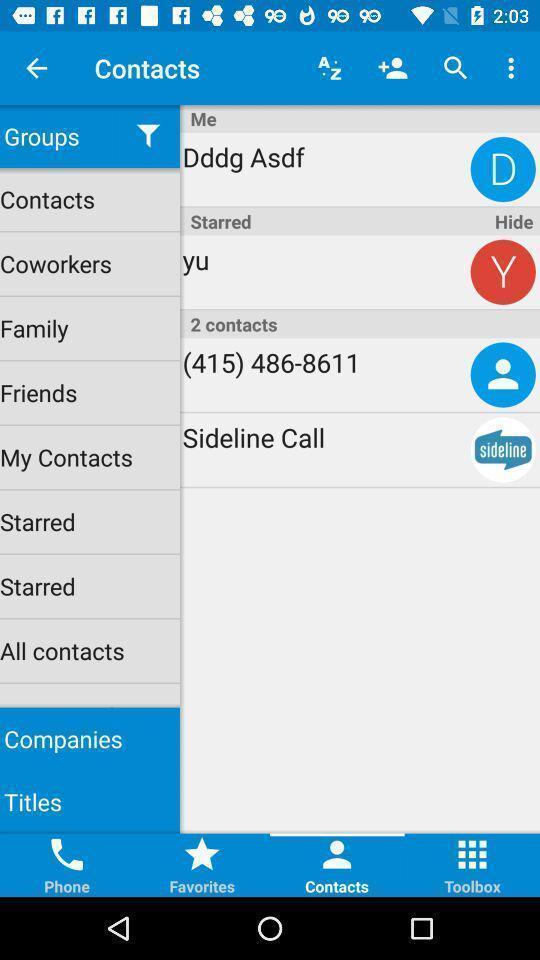Describe this image in words. Page shows menu list in the contacts app. 